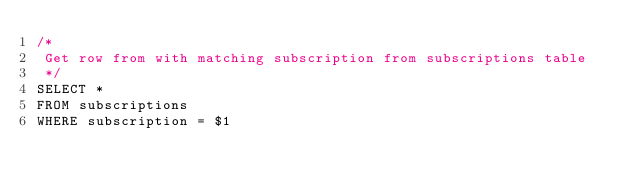Convert code to text. <code><loc_0><loc_0><loc_500><loc_500><_SQL_>/*
 Get row from with matching subscription from subscriptions table
 */
SELECT *
FROM subscriptions
WHERE subscription = $1</code> 